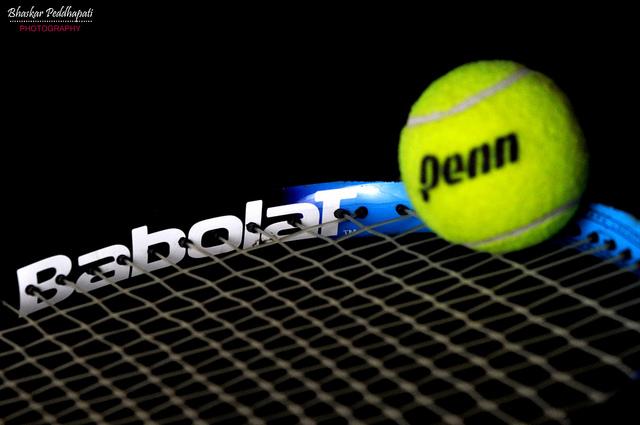What color is the top portion of the racquet?
Be succinct. Blue. Where is the photographer's logo?
Write a very short answer. Top left. Is the ball in the photo being used to play fetch?
Answer briefly. No. 